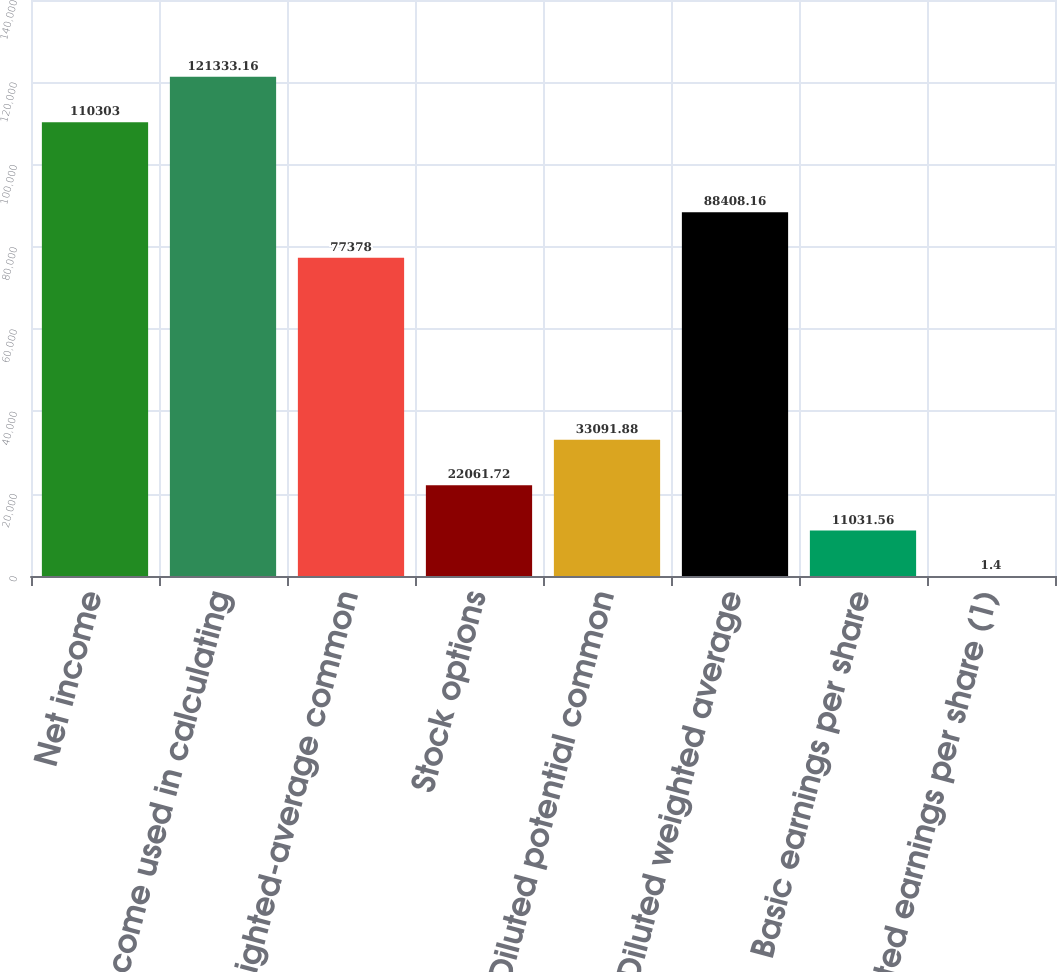Convert chart. <chart><loc_0><loc_0><loc_500><loc_500><bar_chart><fcel>Net income<fcel>Net income used in calculating<fcel>Basic weighted-average common<fcel>Stock options<fcel>Diluted potential common<fcel>Diluted weighted average<fcel>Basic earnings per share<fcel>Diluted earnings per share (1)<nl><fcel>110303<fcel>121333<fcel>77378<fcel>22061.7<fcel>33091.9<fcel>88408.2<fcel>11031.6<fcel>1.4<nl></chart> 